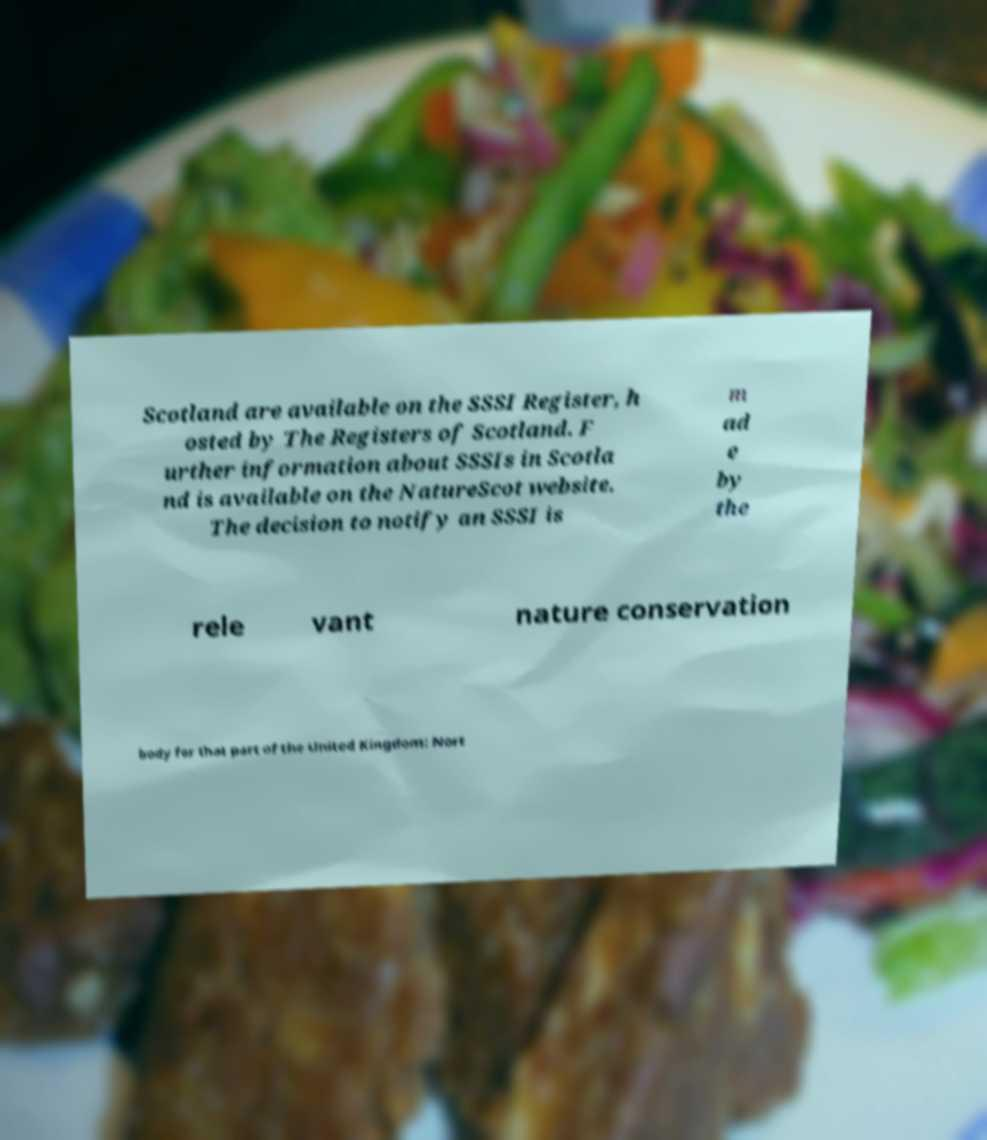For documentation purposes, I need the text within this image transcribed. Could you provide that? Scotland are available on the SSSI Register, h osted by The Registers of Scotland. F urther information about SSSIs in Scotla nd is available on the NatureScot website. The decision to notify an SSSI is m ad e by the rele vant nature conservation body for that part of the United Kingdom: Nort 